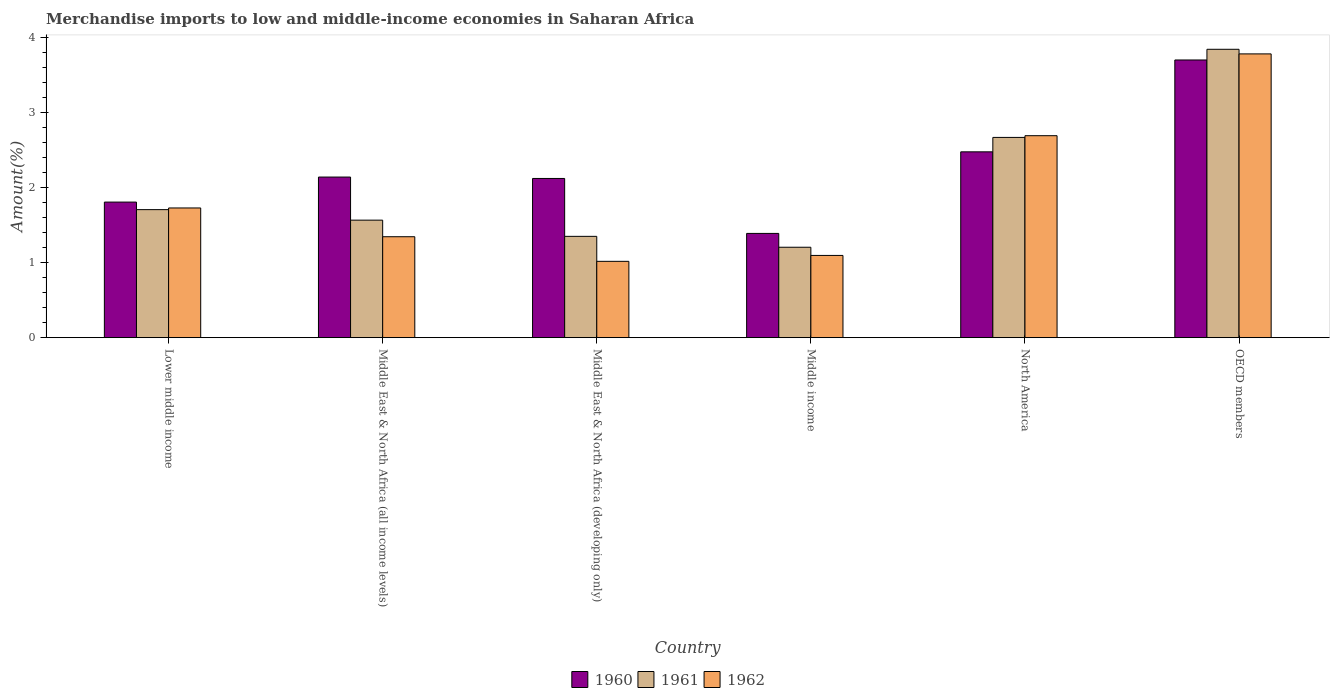How many different coloured bars are there?
Your answer should be compact. 3. How many groups of bars are there?
Ensure brevity in your answer.  6. Are the number of bars on each tick of the X-axis equal?
Make the answer very short. Yes. How many bars are there on the 6th tick from the left?
Keep it short and to the point. 3. How many bars are there on the 1st tick from the right?
Provide a short and direct response. 3. What is the label of the 6th group of bars from the left?
Ensure brevity in your answer.  OECD members. In how many cases, is the number of bars for a given country not equal to the number of legend labels?
Ensure brevity in your answer.  0. What is the percentage of amount earned from merchandise imports in 1961 in Middle East & North Africa (all income levels)?
Your response must be concise. 1.57. Across all countries, what is the maximum percentage of amount earned from merchandise imports in 1961?
Your answer should be very brief. 3.84. Across all countries, what is the minimum percentage of amount earned from merchandise imports in 1962?
Make the answer very short. 1.02. In which country was the percentage of amount earned from merchandise imports in 1960 minimum?
Make the answer very short. Middle income. What is the total percentage of amount earned from merchandise imports in 1962 in the graph?
Provide a short and direct response. 11.65. What is the difference between the percentage of amount earned from merchandise imports in 1961 in Lower middle income and that in North America?
Give a very brief answer. -0.96. What is the difference between the percentage of amount earned from merchandise imports in 1960 in OECD members and the percentage of amount earned from merchandise imports in 1962 in Lower middle income?
Your response must be concise. 1.97. What is the average percentage of amount earned from merchandise imports in 1960 per country?
Your answer should be compact. 2.27. What is the difference between the percentage of amount earned from merchandise imports of/in 1961 and percentage of amount earned from merchandise imports of/in 1962 in Middle East & North Africa (developing only)?
Your answer should be very brief. 0.33. In how many countries, is the percentage of amount earned from merchandise imports in 1961 greater than 3.4 %?
Provide a succinct answer. 1. What is the ratio of the percentage of amount earned from merchandise imports in 1961 in Middle East & North Africa (developing only) to that in Middle income?
Ensure brevity in your answer.  1.12. Is the percentage of amount earned from merchandise imports in 1961 in Lower middle income less than that in North America?
Your answer should be very brief. Yes. What is the difference between the highest and the second highest percentage of amount earned from merchandise imports in 1960?
Make the answer very short. -1.22. What is the difference between the highest and the lowest percentage of amount earned from merchandise imports in 1960?
Make the answer very short. 2.31. In how many countries, is the percentage of amount earned from merchandise imports in 1960 greater than the average percentage of amount earned from merchandise imports in 1960 taken over all countries?
Provide a short and direct response. 2. Is the sum of the percentage of amount earned from merchandise imports in 1962 in Lower middle income and OECD members greater than the maximum percentage of amount earned from merchandise imports in 1961 across all countries?
Ensure brevity in your answer.  Yes. Does the graph contain grids?
Ensure brevity in your answer.  No. Where does the legend appear in the graph?
Offer a very short reply. Bottom center. How many legend labels are there?
Your answer should be very brief. 3. What is the title of the graph?
Give a very brief answer. Merchandise imports to low and middle-income economies in Saharan Africa. Does "1966" appear as one of the legend labels in the graph?
Give a very brief answer. No. What is the label or title of the Y-axis?
Provide a short and direct response. Amount(%). What is the Amount(%) of 1960 in Lower middle income?
Your answer should be very brief. 1.81. What is the Amount(%) in 1961 in Lower middle income?
Your response must be concise. 1.71. What is the Amount(%) in 1962 in Lower middle income?
Give a very brief answer. 1.73. What is the Amount(%) in 1960 in Middle East & North Africa (all income levels)?
Provide a succinct answer. 2.14. What is the Amount(%) in 1961 in Middle East & North Africa (all income levels)?
Make the answer very short. 1.57. What is the Amount(%) of 1962 in Middle East & North Africa (all income levels)?
Ensure brevity in your answer.  1.34. What is the Amount(%) in 1960 in Middle East & North Africa (developing only)?
Your answer should be very brief. 2.12. What is the Amount(%) in 1961 in Middle East & North Africa (developing only)?
Your answer should be compact. 1.35. What is the Amount(%) of 1962 in Middle East & North Africa (developing only)?
Provide a short and direct response. 1.02. What is the Amount(%) in 1960 in Middle income?
Your response must be concise. 1.39. What is the Amount(%) in 1961 in Middle income?
Provide a succinct answer. 1.2. What is the Amount(%) in 1962 in Middle income?
Ensure brevity in your answer.  1.1. What is the Amount(%) of 1960 in North America?
Give a very brief answer. 2.47. What is the Amount(%) in 1961 in North America?
Keep it short and to the point. 2.67. What is the Amount(%) in 1962 in North America?
Keep it short and to the point. 2.69. What is the Amount(%) of 1960 in OECD members?
Your answer should be very brief. 3.7. What is the Amount(%) in 1961 in OECD members?
Offer a very short reply. 3.84. What is the Amount(%) in 1962 in OECD members?
Your answer should be very brief. 3.78. Across all countries, what is the maximum Amount(%) of 1960?
Provide a succinct answer. 3.7. Across all countries, what is the maximum Amount(%) of 1961?
Make the answer very short. 3.84. Across all countries, what is the maximum Amount(%) in 1962?
Your response must be concise. 3.78. Across all countries, what is the minimum Amount(%) of 1960?
Provide a short and direct response. 1.39. Across all countries, what is the minimum Amount(%) of 1961?
Keep it short and to the point. 1.2. Across all countries, what is the minimum Amount(%) in 1962?
Your answer should be compact. 1.02. What is the total Amount(%) of 1960 in the graph?
Offer a very short reply. 13.63. What is the total Amount(%) of 1961 in the graph?
Make the answer very short. 12.33. What is the total Amount(%) in 1962 in the graph?
Give a very brief answer. 11.65. What is the difference between the Amount(%) of 1960 in Lower middle income and that in Middle East & North Africa (all income levels)?
Your answer should be compact. -0.33. What is the difference between the Amount(%) in 1961 in Lower middle income and that in Middle East & North Africa (all income levels)?
Your answer should be compact. 0.14. What is the difference between the Amount(%) of 1962 in Lower middle income and that in Middle East & North Africa (all income levels)?
Your response must be concise. 0.38. What is the difference between the Amount(%) of 1960 in Lower middle income and that in Middle East & North Africa (developing only)?
Give a very brief answer. -0.31. What is the difference between the Amount(%) in 1961 in Lower middle income and that in Middle East & North Africa (developing only)?
Provide a short and direct response. 0.36. What is the difference between the Amount(%) of 1962 in Lower middle income and that in Middle East & North Africa (developing only)?
Offer a terse response. 0.71. What is the difference between the Amount(%) in 1960 in Lower middle income and that in Middle income?
Offer a very short reply. 0.42. What is the difference between the Amount(%) of 1961 in Lower middle income and that in Middle income?
Your answer should be compact. 0.5. What is the difference between the Amount(%) in 1962 in Lower middle income and that in Middle income?
Your answer should be very brief. 0.63. What is the difference between the Amount(%) in 1960 in Lower middle income and that in North America?
Provide a short and direct response. -0.67. What is the difference between the Amount(%) in 1961 in Lower middle income and that in North America?
Ensure brevity in your answer.  -0.96. What is the difference between the Amount(%) in 1962 in Lower middle income and that in North America?
Offer a very short reply. -0.96. What is the difference between the Amount(%) of 1960 in Lower middle income and that in OECD members?
Your response must be concise. -1.89. What is the difference between the Amount(%) of 1961 in Lower middle income and that in OECD members?
Keep it short and to the point. -2.14. What is the difference between the Amount(%) in 1962 in Lower middle income and that in OECD members?
Make the answer very short. -2.05. What is the difference between the Amount(%) in 1960 in Middle East & North Africa (all income levels) and that in Middle East & North Africa (developing only)?
Keep it short and to the point. 0.02. What is the difference between the Amount(%) of 1961 in Middle East & North Africa (all income levels) and that in Middle East & North Africa (developing only)?
Your answer should be very brief. 0.22. What is the difference between the Amount(%) of 1962 in Middle East & North Africa (all income levels) and that in Middle East & North Africa (developing only)?
Provide a succinct answer. 0.33. What is the difference between the Amount(%) in 1960 in Middle East & North Africa (all income levels) and that in Middle income?
Your response must be concise. 0.75. What is the difference between the Amount(%) in 1961 in Middle East & North Africa (all income levels) and that in Middle income?
Keep it short and to the point. 0.36. What is the difference between the Amount(%) in 1962 in Middle East & North Africa (all income levels) and that in Middle income?
Give a very brief answer. 0.25. What is the difference between the Amount(%) in 1960 in Middle East & North Africa (all income levels) and that in North America?
Keep it short and to the point. -0.34. What is the difference between the Amount(%) in 1961 in Middle East & North Africa (all income levels) and that in North America?
Make the answer very short. -1.1. What is the difference between the Amount(%) in 1962 in Middle East & North Africa (all income levels) and that in North America?
Ensure brevity in your answer.  -1.35. What is the difference between the Amount(%) of 1960 in Middle East & North Africa (all income levels) and that in OECD members?
Offer a terse response. -1.56. What is the difference between the Amount(%) of 1961 in Middle East & North Africa (all income levels) and that in OECD members?
Provide a succinct answer. -2.28. What is the difference between the Amount(%) of 1962 in Middle East & North Africa (all income levels) and that in OECD members?
Give a very brief answer. -2.44. What is the difference between the Amount(%) of 1960 in Middle East & North Africa (developing only) and that in Middle income?
Offer a terse response. 0.73. What is the difference between the Amount(%) of 1961 in Middle East & North Africa (developing only) and that in Middle income?
Keep it short and to the point. 0.15. What is the difference between the Amount(%) of 1962 in Middle East & North Africa (developing only) and that in Middle income?
Your response must be concise. -0.08. What is the difference between the Amount(%) of 1960 in Middle East & North Africa (developing only) and that in North America?
Your answer should be very brief. -0.35. What is the difference between the Amount(%) in 1961 in Middle East & North Africa (developing only) and that in North America?
Offer a very short reply. -1.32. What is the difference between the Amount(%) of 1962 in Middle East & North Africa (developing only) and that in North America?
Provide a succinct answer. -1.67. What is the difference between the Amount(%) in 1960 in Middle East & North Africa (developing only) and that in OECD members?
Make the answer very short. -1.58. What is the difference between the Amount(%) in 1961 in Middle East & North Africa (developing only) and that in OECD members?
Offer a very short reply. -2.49. What is the difference between the Amount(%) of 1962 in Middle East & North Africa (developing only) and that in OECD members?
Your answer should be compact. -2.76. What is the difference between the Amount(%) in 1960 in Middle income and that in North America?
Provide a short and direct response. -1.09. What is the difference between the Amount(%) of 1961 in Middle income and that in North America?
Make the answer very short. -1.46. What is the difference between the Amount(%) in 1962 in Middle income and that in North America?
Give a very brief answer. -1.59. What is the difference between the Amount(%) in 1960 in Middle income and that in OECD members?
Your answer should be compact. -2.31. What is the difference between the Amount(%) of 1961 in Middle income and that in OECD members?
Provide a short and direct response. -2.64. What is the difference between the Amount(%) in 1962 in Middle income and that in OECD members?
Provide a succinct answer. -2.68. What is the difference between the Amount(%) in 1960 in North America and that in OECD members?
Offer a terse response. -1.22. What is the difference between the Amount(%) of 1961 in North America and that in OECD members?
Provide a succinct answer. -1.17. What is the difference between the Amount(%) in 1962 in North America and that in OECD members?
Your response must be concise. -1.09. What is the difference between the Amount(%) of 1960 in Lower middle income and the Amount(%) of 1961 in Middle East & North Africa (all income levels)?
Your answer should be very brief. 0.24. What is the difference between the Amount(%) in 1960 in Lower middle income and the Amount(%) in 1962 in Middle East & North Africa (all income levels)?
Ensure brevity in your answer.  0.46. What is the difference between the Amount(%) in 1961 in Lower middle income and the Amount(%) in 1962 in Middle East & North Africa (all income levels)?
Provide a short and direct response. 0.36. What is the difference between the Amount(%) of 1960 in Lower middle income and the Amount(%) of 1961 in Middle East & North Africa (developing only)?
Make the answer very short. 0.46. What is the difference between the Amount(%) in 1960 in Lower middle income and the Amount(%) in 1962 in Middle East & North Africa (developing only)?
Offer a very short reply. 0.79. What is the difference between the Amount(%) in 1961 in Lower middle income and the Amount(%) in 1962 in Middle East & North Africa (developing only)?
Offer a very short reply. 0.69. What is the difference between the Amount(%) of 1960 in Lower middle income and the Amount(%) of 1961 in Middle income?
Provide a short and direct response. 0.6. What is the difference between the Amount(%) in 1960 in Lower middle income and the Amount(%) in 1962 in Middle income?
Keep it short and to the point. 0.71. What is the difference between the Amount(%) of 1961 in Lower middle income and the Amount(%) of 1962 in Middle income?
Offer a very short reply. 0.61. What is the difference between the Amount(%) in 1960 in Lower middle income and the Amount(%) in 1961 in North America?
Your response must be concise. -0.86. What is the difference between the Amount(%) in 1960 in Lower middle income and the Amount(%) in 1962 in North America?
Your answer should be very brief. -0.88. What is the difference between the Amount(%) of 1961 in Lower middle income and the Amount(%) of 1962 in North America?
Your answer should be very brief. -0.98. What is the difference between the Amount(%) of 1960 in Lower middle income and the Amount(%) of 1961 in OECD members?
Offer a terse response. -2.04. What is the difference between the Amount(%) in 1960 in Lower middle income and the Amount(%) in 1962 in OECD members?
Offer a very short reply. -1.97. What is the difference between the Amount(%) of 1961 in Lower middle income and the Amount(%) of 1962 in OECD members?
Your answer should be compact. -2.07. What is the difference between the Amount(%) in 1960 in Middle East & North Africa (all income levels) and the Amount(%) in 1961 in Middle East & North Africa (developing only)?
Your answer should be compact. 0.79. What is the difference between the Amount(%) of 1960 in Middle East & North Africa (all income levels) and the Amount(%) of 1962 in Middle East & North Africa (developing only)?
Ensure brevity in your answer.  1.12. What is the difference between the Amount(%) in 1961 in Middle East & North Africa (all income levels) and the Amount(%) in 1962 in Middle East & North Africa (developing only)?
Offer a terse response. 0.55. What is the difference between the Amount(%) in 1960 in Middle East & North Africa (all income levels) and the Amount(%) in 1961 in Middle income?
Provide a short and direct response. 0.93. What is the difference between the Amount(%) in 1960 in Middle East & North Africa (all income levels) and the Amount(%) in 1962 in Middle income?
Keep it short and to the point. 1.04. What is the difference between the Amount(%) of 1961 in Middle East & North Africa (all income levels) and the Amount(%) of 1962 in Middle income?
Your answer should be very brief. 0.47. What is the difference between the Amount(%) of 1960 in Middle East & North Africa (all income levels) and the Amount(%) of 1961 in North America?
Offer a very short reply. -0.53. What is the difference between the Amount(%) of 1960 in Middle East & North Africa (all income levels) and the Amount(%) of 1962 in North America?
Provide a succinct answer. -0.55. What is the difference between the Amount(%) in 1961 in Middle East & North Africa (all income levels) and the Amount(%) in 1962 in North America?
Offer a very short reply. -1.12. What is the difference between the Amount(%) of 1960 in Middle East & North Africa (all income levels) and the Amount(%) of 1961 in OECD members?
Make the answer very short. -1.7. What is the difference between the Amount(%) in 1960 in Middle East & North Africa (all income levels) and the Amount(%) in 1962 in OECD members?
Your answer should be compact. -1.64. What is the difference between the Amount(%) of 1961 in Middle East & North Africa (all income levels) and the Amount(%) of 1962 in OECD members?
Offer a very short reply. -2.21. What is the difference between the Amount(%) in 1960 in Middle East & North Africa (developing only) and the Amount(%) in 1961 in Middle income?
Offer a very short reply. 0.92. What is the difference between the Amount(%) of 1960 in Middle East & North Africa (developing only) and the Amount(%) of 1962 in Middle income?
Your response must be concise. 1.03. What is the difference between the Amount(%) in 1961 in Middle East & North Africa (developing only) and the Amount(%) in 1962 in Middle income?
Provide a short and direct response. 0.25. What is the difference between the Amount(%) in 1960 in Middle East & North Africa (developing only) and the Amount(%) in 1961 in North America?
Provide a short and direct response. -0.55. What is the difference between the Amount(%) of 1960 in Middle East & North Africa (developing only) and the Amount(%) of 1962 in North America?
Make the answer very short. -0.57. What is the difference between the Amount(%) in 1961 in Middle East & North Africa (developing only) and the Amount(%) in 1962 in North America?
Make the answer very short. -1.34. What is the difference between the Amount(%) of 1960 in Middle East & North Africa (developing only) and the Amount(%) of 1961 in OECD members?
Ensure brevity in your answer.  -1.72. What is the difference between the Amount(%) in 1960 in Middle East & North Africa (developing only) and the Amount(%) in 1962 in OECD members?
Keep it short and to the point. -1.66. What is the difference between the Amount(%) of 1961 in Middle East & North Africa (developing only) and the Amount(%) of 1962 in OECD members?
Provide a short and direct response. -2.43. What is the difference between the Amount(%) in 1960 in Middle income and the Amount(%) in 1961 in North America?
Give a very brief answer. -1.28. What is the difference between the Amount(%) in 1960 in Middle income and the Amount(%) in 1962 in North America?
Your response must be concise. -1.3. What is the difference between the Amount(%) in 1961 in Middle income and the Amount(%) in 1962 in North America?
Make the answer very short. -1.49. What is the difference between the Amount(%) of 1960 in Middle income and the Amount(%) of 1961 in OECD members?
Ensure brevity in your answer.  -2.45. What is the difference between the Amount(%) in 1960 in Middle income and the Amount(%) in 1962 in OECD members?
Keep it short and to the point. -2.39. What is the difference between the Amount(%) in 1961 in Middle income and the Amount(%) in 1962 in OECD members?
Keep it short and to the point. -2.58. What is the difference between the Amount(%) of 1960 in North America and the Amount(%) of 1961 in OECD members?
Offer a terse response. -1.37. What is the difference between the Amount(%) of 1960 in North America and the Amount(%) of 1962 in OECD members?
Offer a terse response. -1.3. What is the difference between the Amount(%) of 1961 in North America and the Amount(%) of 1962 in OECD members?
Your answer should be very brief. -1.11. What is the average Amount(%) in 1960 per country?
Keep it short and to the point. 2.27. What is the average Amount(%) of 1961 per country?
Your answer should be very brief. 2.06. What is the average Amount(%) in 1962 per country?
Provide a succinct answer. 1.94. What is the difference between the Amount(%) in 1960 and Amount(%) in 1961 in Lower middle income?
Offer a very short reply. 0.1. What is the difference between the Amount(%) in 1960 and Amount(%) in 1962 in Lower middle income?
Keep it short and to the point. 0.08. What is the difference between the Amount(%) in 1961 and Amount(%) in 1962 in Lower middle income?
Offer a very short reply. -0.02. What is the difference between the Amount(%) of 1960 and Amount(%) of 1961 in Middle East & North Africa (all income levels)?
Offer a terse response. 0.57. What is the difference between the Amount(%) in 1960 and Amount(%) in 1962 in Middle East & North Africa (all income levels)?
Make the answer very short. 0.79. What is the difference between the Amount(%) in 1961 and Amount(%) in 1962 in Middle East & North Africa (all income levels)?
Offer a very short reply. 0.22. What is the difference between the Amount(%) of 1960 and Amount(%) of 1961 in Middle East & North Africa (developing only)?
Your answer should be very brief. 0.77. What is the difference between the Amount(%) of 1960 and Amount(%) of 1962 in Middle East & North Africa (developing only)?
Offer a very short reply. 1.1. What is the difference between the Amount(%) of 1961 and Amount(%) of 1962 in Middle East & North Africa (developing only)?
Give a very brief answer. 0.33. What is the difference between the Amount(%) in 1960 and Amount(%) in 1961 in Middle income?
Keep it short and to the point. 0.18. What is the difference between the Amount(%) of 1960 and Amount(%) of 1962 in Middle income?
Offer a very short reply. 0.29. What is the difference between the Amount(%) of 1961 and Amount(%) of 1962 in Middle income?
Give a very brief answer. 0.11. What is the difference between the Amount(%) in 1960 and Amount(%) in 1961 in North America?
Ensure brevity in your answer.  -0.19. What is the difference between the Amount(%) of 1960 and Amount(%) of 1962 in North America?
Keep it short and to the point. -0.21. What is the difference between the Amount(%) in 1961 and Amount(%) in 1962 in North America?
Your answer should be very brief. -0.02. What is the difference between the Amount(%) of 1960 and Amount(%) of 1961 in OECD members?
Provide a short and direct response. -0.14. What is the difference between the Amount(%) of 1960 and Amount(%) of 1962 in OECD members?
Your response must be concise. -0.08. What is the difference between the Amount(%) in 1961 and Amount(%) in 1962 in OECD members?
Provide a short and direct response. 0.06. What is the ratio of the Amount(%) in 1960 in Lower middle income to that in Middle East & North Africa (all income levels)?
Keep it short and to the point. 0.84. What is the ratio of the Amount(%) of 1961 in Lower middle income to that in Middle East & North Africa (all income levels)?
Make the answer very short. 1.09. What is the ratio of the Amount(%) in 1962 in Lower middle income to that in Middle East & North Africa (all income levels)?
Keep it short and to the point. 1.28. What is the ratio of the Amount(%) of 1960 in Lower middle income to that in Middle East & North Africa (developing only)?
Give a very brief answer. 0.85. What is the ratio of the Amount(%) in 1961 in Lower middle income to that in Middle East & North Africa (developing only)?
Your answer should be very brief. 1.26. What is the ratio of the Amount(%) of 1962 in Lower middle income to that in Middle East & North Africa (developing only)?
Offer a terse response. 1.7. What is the ratio of the Amount(%) of 1960 in Lower middle income to that in Middle income?
Offer a very short reply. 1.3. What is the ratio of the Amount(%) in 1961 in Lower middle income to that in Middle income?
Your answer should be very brief. 1.42. What is the ratio of the Amount(%) of 1962 in Lower middle income to that in Middle income?
Give a very brief answer. 1.58. What is the ratio of the Amount(%) of 1960 in Lower middle income to that in North America?
Offer a very short reply. 0.73. What is the ratio of the Amount(%) of 1961 in Lower middle income to that in North America?
Offer a terse response. 0.64. What is the ratio of the Amount(%) of 1962 in Lower middle income to that in North America?
Provide a short and direct response. 0.64. What is the ratio of the Amount(%) in 1960 in Lower middle income to that in OECD members?
Your answer should be very brief. 0.49. What is the ratio of the Amount(%) in 1961 in Lower middle income to that in OECD members?
Offer a very short reply. 0.44. What is the ratio of the Amount(%) of 1962 in Lower middle income to that in OECD members?
Provide a short and direct response. 0.46. What is the ratio of the Amount(%) of 1960 in Middle East & North Africa (all income levels) to that in Middle East & North Africa (developing only)?
Make the answer very short. 1.01. What is the ratio of the Amount(%) in 1961 in Middle East & North Africa (all income levels) to that in Middle East & North Africa (developing only)?
Make the answer very short. 1.16. What is the ratio of the Amount(%) in 1962 in Middle East & North Africa (all income levels) to that in Middle East & North Africa (developing only)?
Offer a very short reply. 1.32. What is the ratio of the Amount(%) in 1960 in Middle East & North Africa (all income levels) to that in Middle income?
Offer a very short reply. 1.54. What is the ratio of the Amount(%) of 1961 in Middle East & North Africa (all income levels) to that in Middle income?
Provide a short and direct response. 1.3. What is the ratio of the Amount(%) of 1962 in Middle East & North Africa (all income levels) to that in Middle income?
Provide a short and direct response. 1.23. What is the ratio of the Amount(%) of 1960 in Middle East & North Africa (all income levels) to that in North America?
Provide a succinct answer. 0.86. What is the ratio of the Amount(%) in 1961 in Middle East & North Africa (all income levels) to that in North America?
Offer a terse response. 0.59. What is the ratio of the Amount(%) of 1962 in Middle East & North Africa (all income levels) to that in North America?
Offer a terse response. 0.5. What is the ratio of the Amount(%) in 1960 in Middle East & North Africa (all income levels) to that in OECD members?
Offer a terse response. 0.58. What is the ratio of the Amount(%) in 1961 in Middle East & North Africa (all income levels) to that in OECD members?
Offer a terse response. 0.41. What is the ratio of the Amount(%) of 1962 in Middle East & North Africa (all income levels) to that in OECD members?
Offer a terse response. 0.36. What is the ratio of the Amount(%) of 1960 in Middle East & North Africa (developing only) to that in Middle income?
Ensure brevity in your answer.  1.53. What is the ratio of the Amount(%) in 1961 in Middle East & North Africa (developing only) to that in Middle income?
Offer a very short reply. 1.12. What is the ratio of the Amount(%) of 1962 in Middle East & North Africa (developing only) to that in Middle income?
Your answer should be very brief. 0.93. What is the ratio of the Amount(%) of 1960 in Middle East & North Africa (developing only) to that in North America?
Give a very brief answer. 0.86. What is the ratio of the Amount(%) in 1961 in Middle East & North Africa (developing only) to that in North America?
Keep it short and to the point. 0.51. What is the ratio of the Amount(%) of 1962 in Middle East & North Africa (developing only) to that in North America?
Offer a very short reply. 0.38. What is the ratio of the Amount(%) of 1960 in Middle East & North Africa (developing only) to that in OECD members?
Ensure brevity in your answer.  0.57. What is the ratio of the Amount(%) of 1961 in Middle East & North Africa (developing only) to that in OECD members?
Your response must be concise. 0.35. What is the ratio of the Amount(%) of 1962 in Middle East & North Africa (developing only) to that in OECD members?
Ensure brevity in your answer.  0.27. What is the ratio of the Amount(%) in 1960 in Middle income to that in North America?
Give a very brief answer. 0.56. What is the ratio of the Amount(%) in 1961 in Middle income to that in North America?
Provide a succinct answer. 0.45. What is the ratio of the Amount(%) of 1962 in Middle income to that in North America?
Give a very brief answer. 0.41. What is the ratio of the Amount(%) in 1960 in Middle income to that in OECD members?
Your answer should be compact. 0.38. What is the ratio of the Amount(%) of 1961 in Middle income to that in OECD members?
Make the answer very short. 0.31. What is the ratio of the Amount(%) of 1962 in Middle income to that in OECD members?
Offer a very short reply. 0.29. What is the ratio of the Amount(%) in 1960 in North America to that in OECD members?
Offer a terse response. 0.67. What is the ratio of the Amount(%) of 1961 in North America to that in OECD members?
Make the answer very short. 0.69. What is the ratio of the Amount(%) of 1962 in North America to that in OECD members?
Ensure brevity in your answer.  0.71. What is the difference between the highest and the second highest Amount(%) of 1960?
Your answer should be very brief. 1.22. What is the difference between the highest and the second highest Amount(%) of 1961?
Ensure brevity in your answer.  1.17. What is the difference between the highest and the second highest Amount(%) in 1962?
Your answer should be compact. 1.09. What is the difference between the highest and the lowest Amount(%) of 1960?
Your answer should be very brief. 2.31. What is the difference between the highest and the lowest Amount(%) of 1961?
Provide a short and direct response. 2.64. What is the difference between the highest and the lowest Amount(%) in 1962?
Make the answer very short. 2.76. 